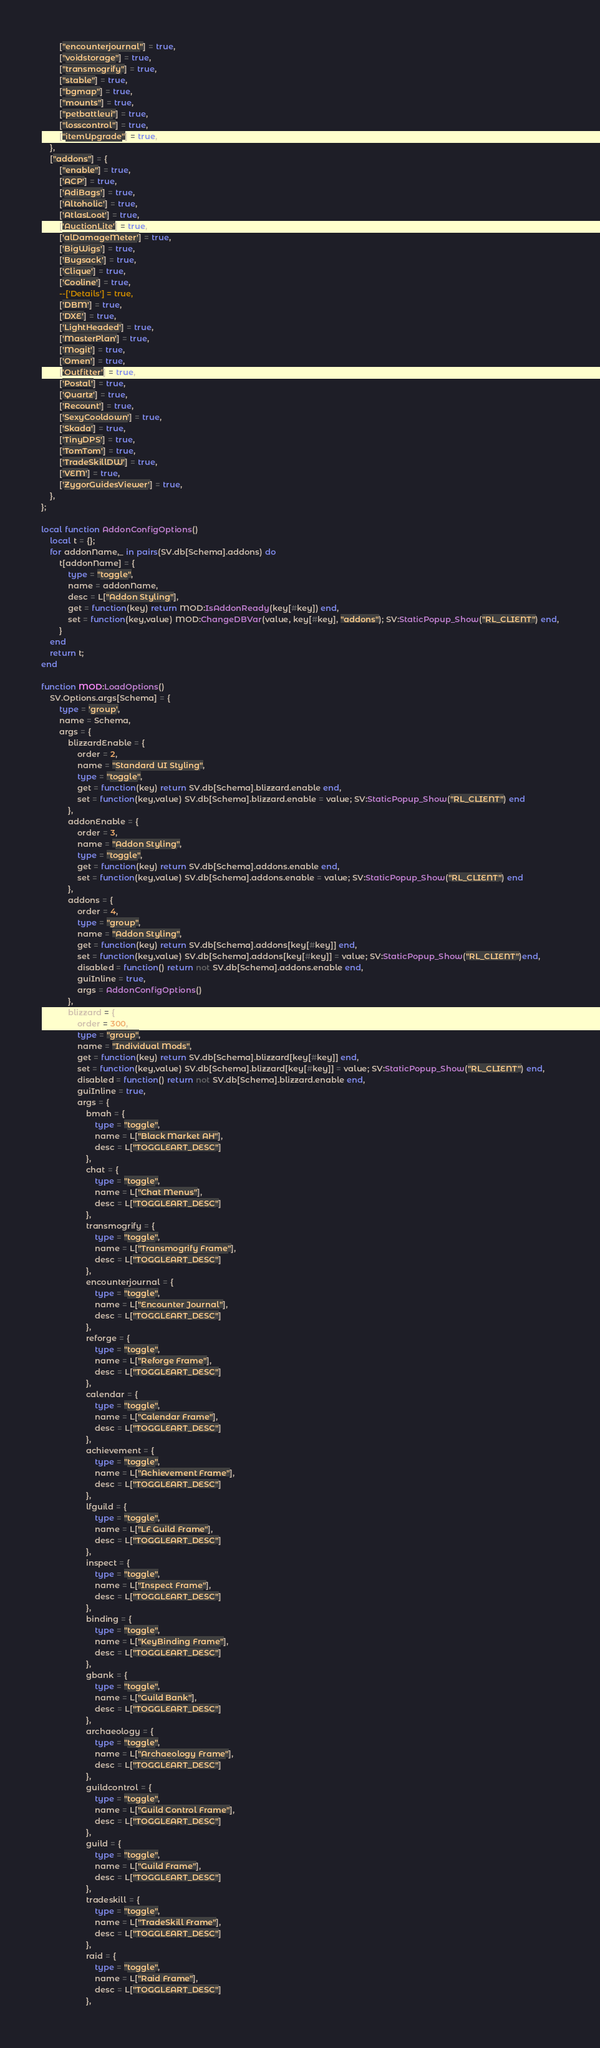<code> <loc_0><loc_0><loc_500><loc_500><_Lua_>		["encounterjournal"] = true, 
		["voidstorage"] = true, 
		["transmogrify"] = true, 
		["stable"] = true, 
		["bgmap"] = true, 
		["mounts"] = true, 
		["petbattleui"] = true, 
		["losscontrol"] = true, 
		["itemUpgrade"] = true, 
	}, 
	["addons"] = {
		["enable"] = true,
		['ACP'] = true,
		['AdiBags'] = true,
		['Altoholic'] = true,
		['AtlasLoot'] = true,
		['AuctionLite'] = true,
		['alDamageMeter'] = true,
		['BigWigs'] = true,
		['Bugsack'] = true,
		['Clique'] = true,
		['Cooline'] = true,
		--['Details'] = true,
		['DBM'] = true,
		['DXE'] = true,
		['LightHeaded'] = true,
		['MasterPlan'] = true,
		['Mogit'] = true,
		['Omen'] = true,
		['Outfitter'] = true,
		['Postal'] = true,
		['Quartz'] = true,
		['Recount'] = true,
		['SexyCooldown'] = true,
		['Skada'] = true,
		['TinyDPS'] = true,
		['TomTom'] = true,
		['TradeSkillDW'] = true,
		['VEM'] = true,
		['ZygorGuidesViewer'] = true,
	},
};

local function AddonConfigOptions()
	local t = {};
	for addonName,_ in pairs(SV.db[Schema].addons) do
		t[addonName] = {
			type = "toggle",
			name = addonName,
			desc = L["Addon Styling"],
			get = function(key) return MOD:IsAddonReady(key[#key]) end,
			set = function(key,value) MOD:ChangeDBVar(value, key[#key], "addons"); SV:StaticPopup_Show("RL_CLIENT") end,
		}
	end
	return t;
end

function MOD:LoadOptions()
	SV.Options.args[Schema] = {
		type = 'group',
		name = Schema,
		args = {
			blizzardEnable = {
			    order = 2, 
				name = "Standard UI Styling", 
			    type = "toggle",
			    get = function(key) return SV.db[Schema].blizzard.enable end,
			    set = function(key,value) SV.db[Schema].blizzard.enable = value; SV:StaticPopup_Show("RL_CLIENT") end
			},
			addonEnable = {
			    order = 3,
				name = "Addon Styling",
			    type = "toggle",
			    get = function(key) return SV.db[Schema].addons.enable end,
			    set = function(key,value) SV.db[Schema].addons.enable = value; SV:StaticPopup_Show("RL_CLIENT") end
			},
			addons = {
				order = 4, 
				type = "group", 
				name = "Addon Styling", 
				get = function(key) return SV.db[Schema].addons[key[#key]] end, 
				set = function(key,value) SV.db[Schema].addons[key[#key]] = value; SV:StaticPopup_Show("RL_CLIENT")end,
				disabled = function() return not SV.db[Schema].addons.enable end,
				guiInline = true, 
				args = AddonConfigOptions()
			},
			blizzard = {
				order = 300, 
				type = "group", 
				name = "Individual Mods", 
				get = function(key) return SV.db[Schema].blizzard[key[#key]] end, 
				set = function(key,value) SV.db[Schema].blizzard[key[#key]] = value; SV:StaticPopup_Show("RL_CLIENT") end, 
				disabled = function() return not SV.db[Schema].blizzard.enable end, 
				guiInline = true, 
				args = {
					bmah = {
						type = "toggle", 
						name = L["Black Market AH"], 
						desc = L["TOGGLEART_DESC"]
					},
					chat = {
						type = "toggle", 
						name = L["Chat Menus"], 
						desc = L["TOGGLEART_DESC"]
					},
					transmogrify = {
						type = "toggle", 
						name = L["Transmogrify Frame"], 
						desc = L["TOGGLEART_DESC"]
					},
					encounterjournal = {
						type = "toggle", 
						name = L["Encounter Journal"], 
						desc = L["TOGGLEART_DESC"]
					},
					reforge = {
						type = "toggle", 
						name = L["Reforge Frame"], 
						desc = L["TOGGLEART_DESC"]
					},
					calendar = {
						type = "toggle", 
						name = L["Calendar Frame"], 
						desc = L["TOGGLEART_DESC"]
					},
					achievement = {
						type = "toggle", 
						name = L["Achievement Frame"], 
						desc = L["TOGGLEART_DESC"]
					},
					lfguild = {
						type = "toggle", 
						name = L["LF Guild Frame"], 
						desc = L["TOGGLEART_DESC"]
					},
					inspect = {
						type = "toggle", 
						name = L["Inspect Frame"], 
						desc = L["TOGGLEART_DESC"]
					},
					binding = {
						type = "toggle", 
						name = L["KeyBinding Frame"], 
						desc = L["TOGGLEART_DESC"]
					},
					gbank = {
						type = "toggle", 
						name = L["Guild Bank"], 
						desc = L["TOGGLEART_DESC"]
					},
					archaeology = {
						type = "toggle", 
						name = L["Archaeology Frame"], 
						desc = L["TOGGLEART_DESC"]
					},
					guildcontrol = {
						type = "toggle", 
						name = L["Guild Control Frame"], 
						desc = L["TOGGLEART_DESC"]
					},
					guild = {
						type = "toggle", 
						name = L["Guild Frame"], 
						desc = L["TOGGLEART_DESC"]
					},
					tradeskill = {
						type = "toggle", 
						name = L["TradeSkill Frame"], 
						desc = L["TOGGLEART_DESC"]
					},
					raid = {
						type = "toggle", 
						name = L["Raid Frame"], 
						desc = L["TOGGLEART_DESC"]
					},</code> 